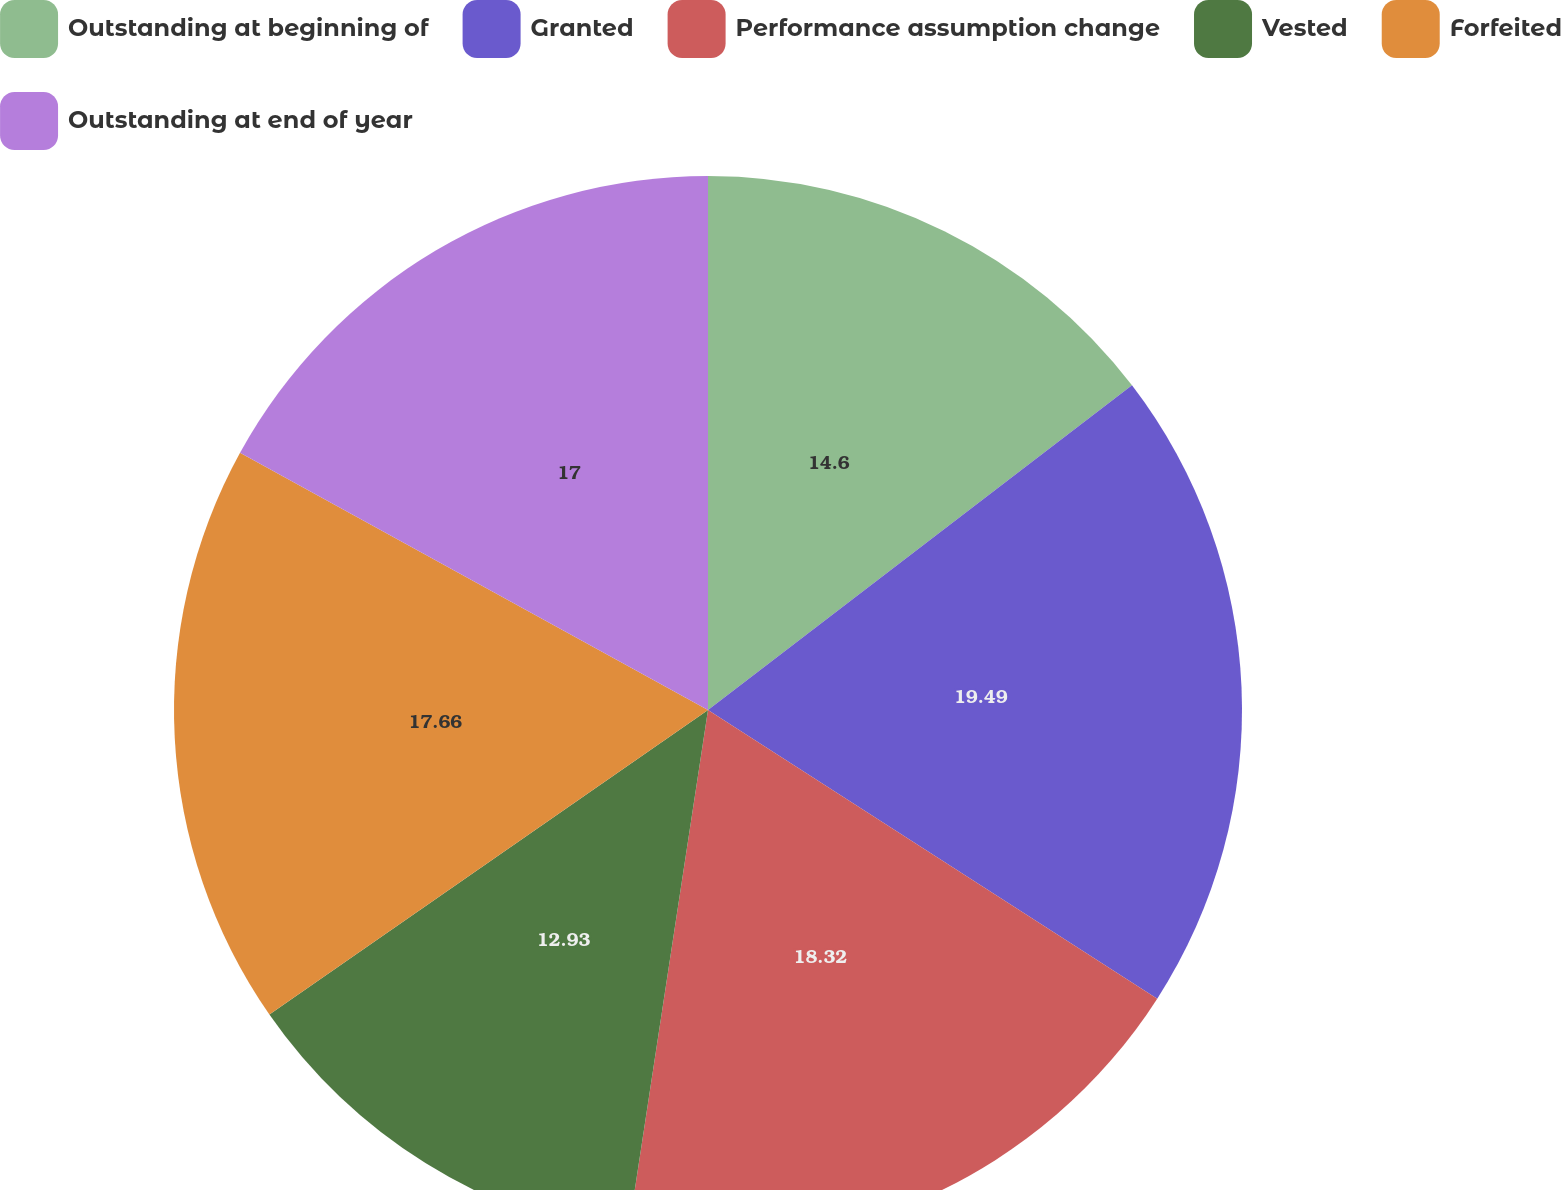Convert chart. <chart><loc_0><loc_0><loc_500><loc_500><pie_chart><fcel>Outstanding at beginning of<fcel>Granted<fcel>Performance assumption change<fcel>Vested<fcel>Forfeited<fcel>Outstanding at end of year<nl><fcel>14.6%<fcel>19.49%<fcel>18.32%<fcel>12.93%<fcel>17.66%<fcel>17.0%<nl></chart> 